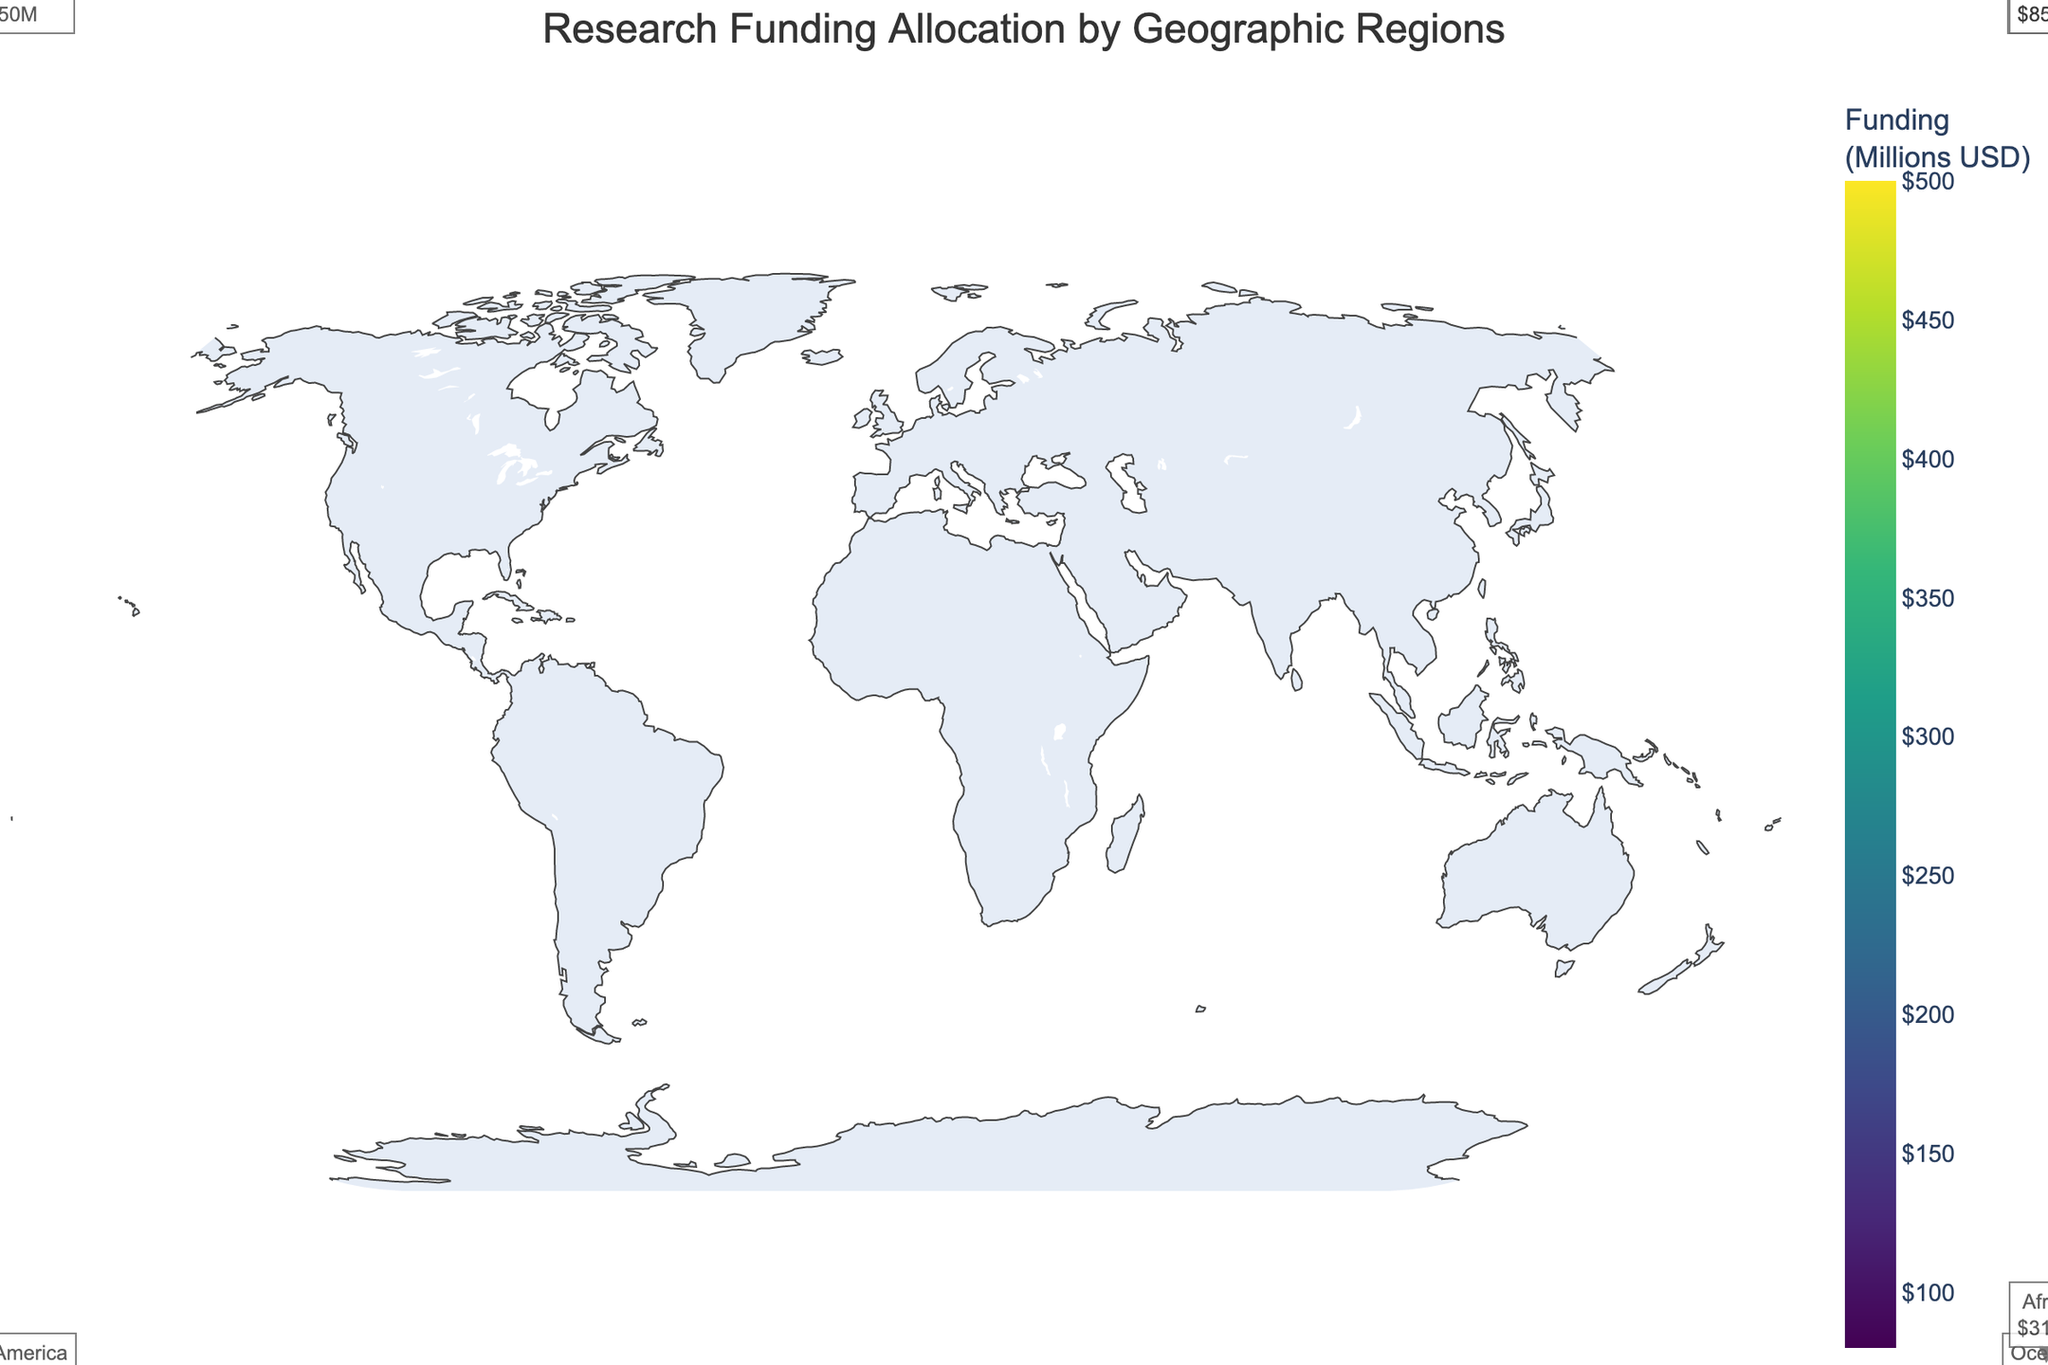What region received the highest overall research funding? North America has three disciplines with high funding: Physics (450M USD), Medicine (500M USD), and Astronomy (300M USD). Adding these amounts (450 + 500 + 300) gives a total of 1250M USD, which is greater than any other region's total funding.
Answer: North America Which academic discipline had the highest research funding in Asia? In Asia, the disciplines listed are Computer Science (320M USD), Neuroscience (280M USD), and Materials Science (250M USD). The highest funding among these is for Computer Science.
Answer: Computer Science What is the total research funding for disciplines in Europe? Europe’s disciplines and their funding are: Biology (380M USD), Mathematics (200M USD), and Psychology (220M USD). Summing these amounts (380 + 200 + 220) results in a total of 800M USD.
Answer: 800M USD Which region has the least funding in Environmental Science? Oceania is the only region listed with Environmental Science funding (180M USD), so it is automatically the least.
Answer: Oceania What is the average funding for academic disciplines in Africa? Africa's disciplines and their funding are: Engineering (120M USD), Agricultural Sciences (90M USD), and Public Health (100M USD). The average is calculated as (120 + 90 + 100) / 3 = 103.33M USD.
Answer: 103.33M USD Which region has higher funding, South America in Chemistry or Oceania in Earth Sciences? South America has 150M USD in Chemistry and Oceania has 160M USD in Earth Sciences. Comparing these, Oceania has higher funding.
Answer: Oceania How many disciplines are represented in the dataset? There is a unique list of disciplines provided: Physics, Biology, Computer Science, Environmental Science, Chemistry, Engineering, Medicine, Mathematics, Neuroscience, Earth Sciences, Economics, Agricultural Sciences, Astronomy, Psychology, Materials Science, Marine Biology, Sociology, Public Health. Counting these, there are 18 distinct disciplines.
Answer: 18 Which region's most funded academic discipline has lower funding, Europe in Biology or Asia in Computer Science? Europe’s highest funded discipline is Biology (380M USD), and Asia's is Computer Science (320M USD). Comparing these, Asia has lower funding.
Answer: Asia What is the total funding in Oceania for all listed disciplines? Oceania’s disciplines and their funding are: Environmental Science (180M USD), Earth Sciences (160M USD), Marine Biology (140M USD). Summing these amounts (180 + 160 + 140) results in a total of 480M USD.
Answer: 480M USD Which region has the highest funding in Medicine? North America is the only region in the dataset with funding in Medicine, which is 500M USD.
Answer: North America 